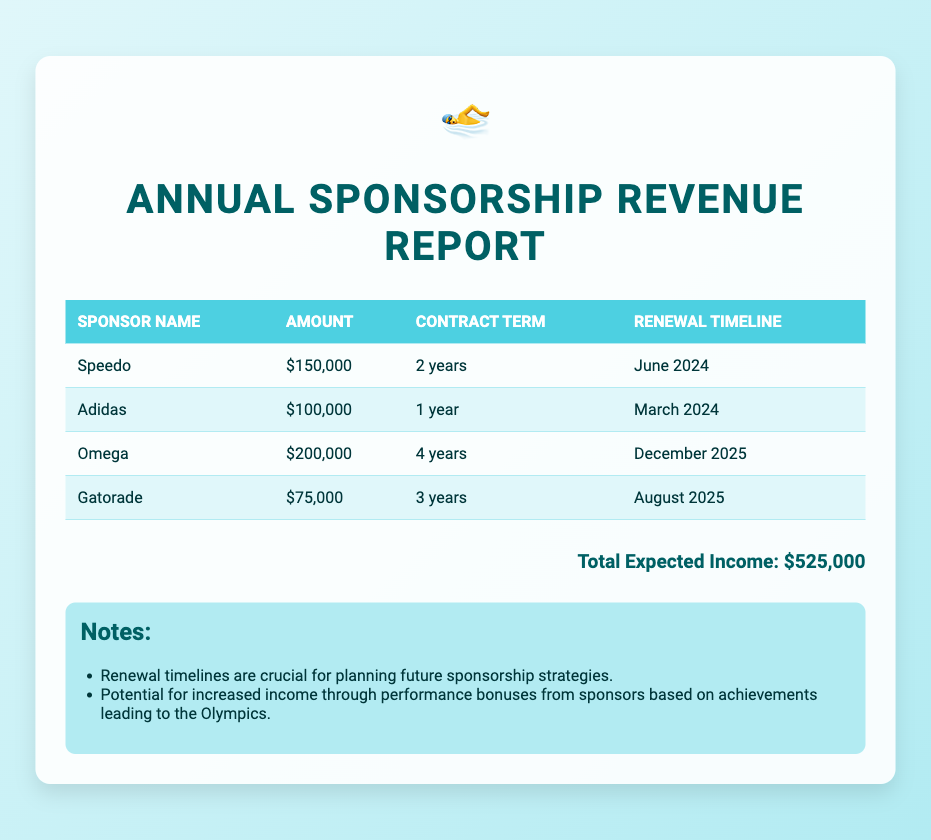What is the total expected income from sponsorships? The total expected income is indicated at the bottom of the document, which sums up all the amounts listed in the table.
Answer: $525,000 What is the contract term with Omega? The contract term is specified in the table under Omega's entry.
Answer: 4 years When does the renewal for Adidas take place? The renewal timeline for Adidas is provided in the table next to Adidas.
Answer: March 2024 How much does Speedo contribute in sponsorship? The amount contributed by Speedo is detailed in the table associated with their name.
Answer: $150,000 Which sponsor has the highest contribution? This requires comparing the amounts in the table to identify the largest figure.
Answer: Omega Which sponsor has the shortest contract term? The shortest contract term is identified by checking the contract terms for each sponsor listed in the table.
Answer: 1 year What is the next renewal due after June 2024? This requires examining the provided renewal timelines in the table to identify the next due date.
Answer: August 2025 What are performance bonuses related to? The notes section mentions that performance bonuses are linked to achievements leading to a specific event.
Answer: Olympics What is the main purpose of the renewal timelines? The document states the purpose of renewal timelines in planning future strategies.
Answer: Planning future sponsorship strategies 